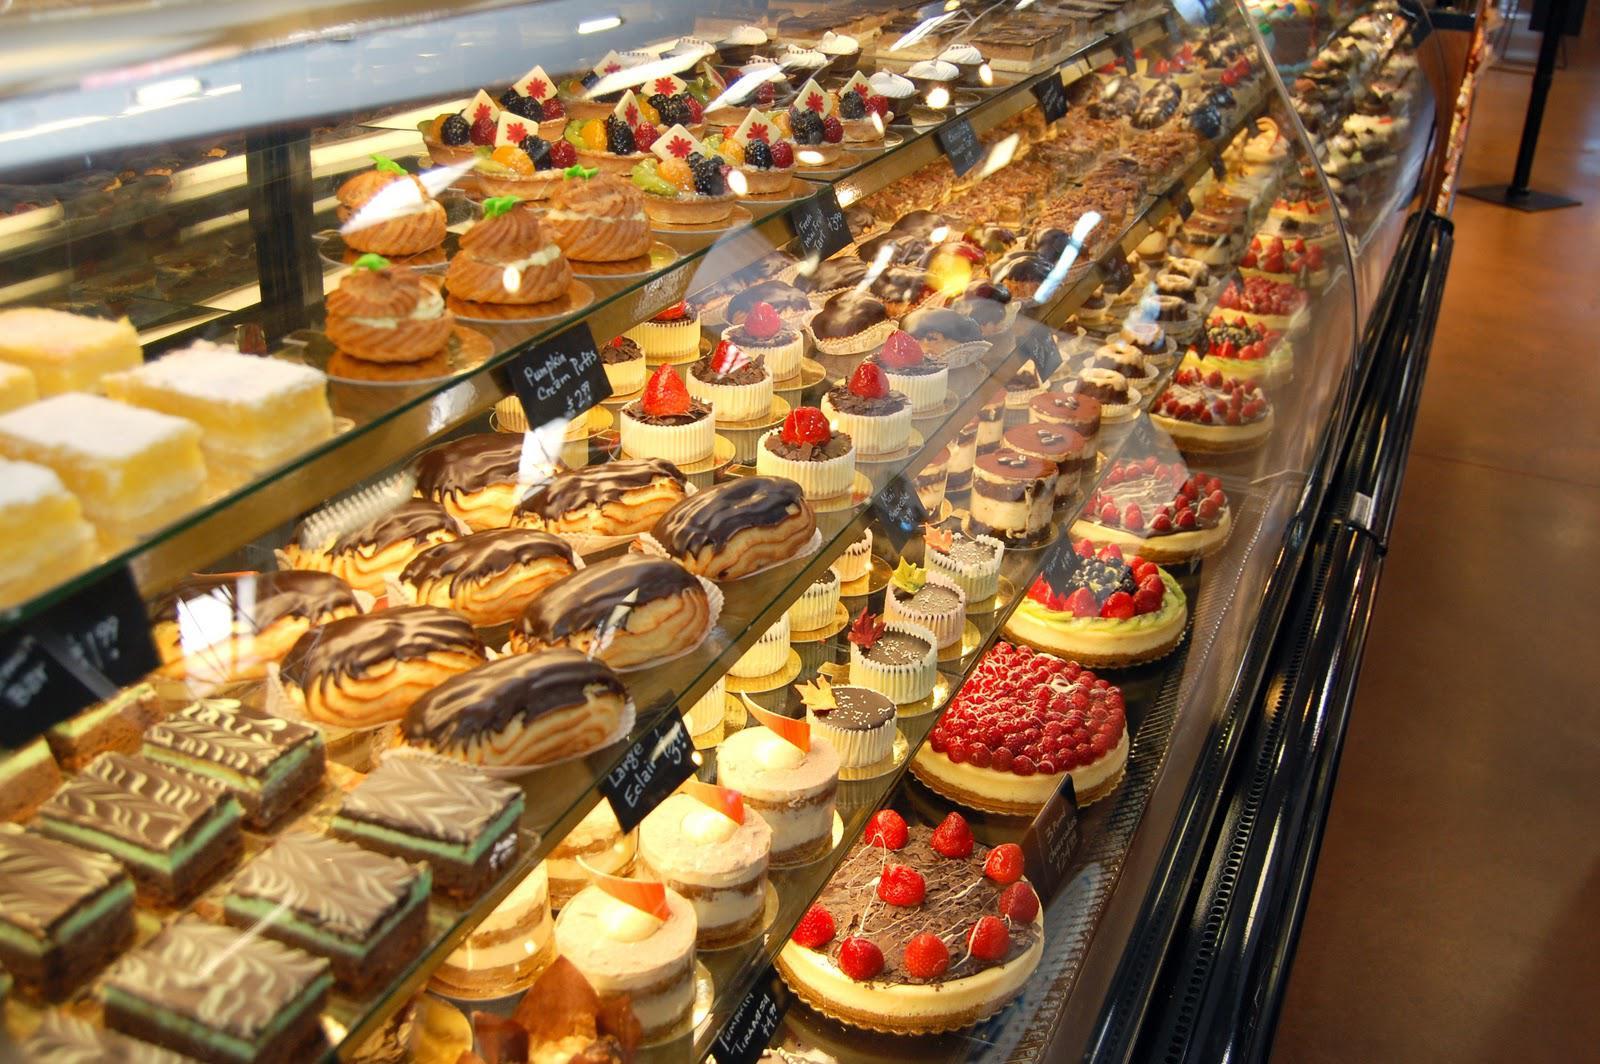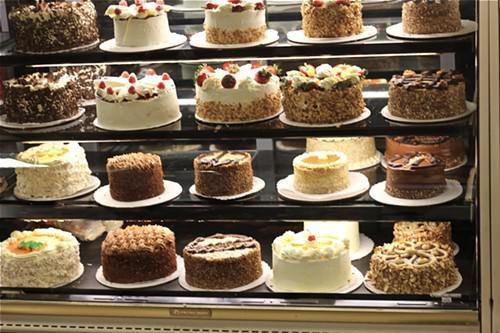The first image is the image on the left, the second image is the image on the right. Evaluate the accuracy of this statement regarding the images: "Lefthand image features a bakery with a white rectangular sign with lettering only.". Is it true? Answer yes or no. No. 